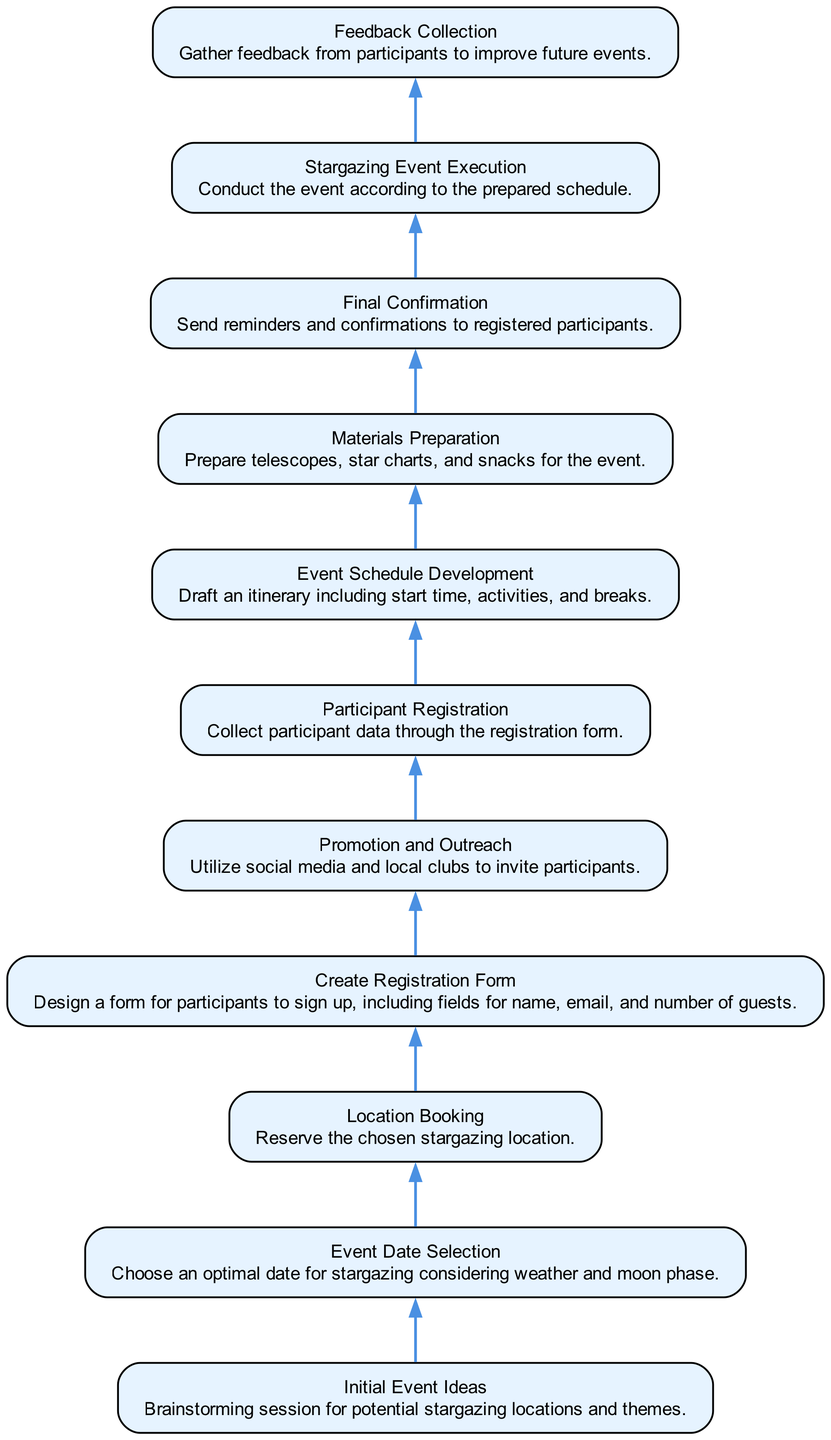What is the first step in the process? The first node in the diagram represents the initial stage of the process, which is "Initial Event Ideas." This node outlines the starting point where potential stargazing locations and themes are brainstormed.
Answer: Initial Event Ideas How many nodes are there in the diagram? By counting all the distinct steps from the beginning to the last, we can determine that there are a total of 11 nodes in the flowchart.
Answer: 11 What is the last step in the planning process? The final node in the diagram shows the last action to be taken, which is "Feedback Collection." This indicates the step where input is gathered from participants after the event.
Answer: Feedback Collection Which step directly follows "Participant Registration"? The flowchart shows that "Event Schedule Development" is the step that comes immediately after "Participant Registration," indicating that the event schedule is drafted following the collection of participant data.
Answer: Event Schedule Development What is required before "Final Confirmation"? The diagram indicates that "Materials Preparation" is necessary to be completed before reaching "Final Confirmation," suggesting that all required materials should be organized prior to sending reminders to participants.
Answer: Materials Preparation Which two steps are necessary before "Stargazing Event Execution"? By tracing the flow, we see that both "Final Confirmation" and "Materials Preparation" must be complete before executing the stargazing event, making these two steps essential for successful event execution.
Answer: Final Confirmation and Materials Preparation What aspect does "Promotion and Outreach" emphasize in the process? This step focuses on the aspect of inviting participants to the stargazing event through various channels, indicating its role in promoting the event to a wider audience.
Answer: Inviting participants What is the purpose of "Create Registration Form"? The purpose of this step is to design a form that enables participants to sign up, ensuring that information such as name, email, and the number of guests is collected effectively.
Answer: To collect participant information How does "Event Date Selection" relate to the overall stargazing planning process? This step is crucial as it determines an optimal date for stargazing activities, taking into consideration both weather conditions and the moon phase, which are vital for a successful experience.
Answer: Determines the optimal date 